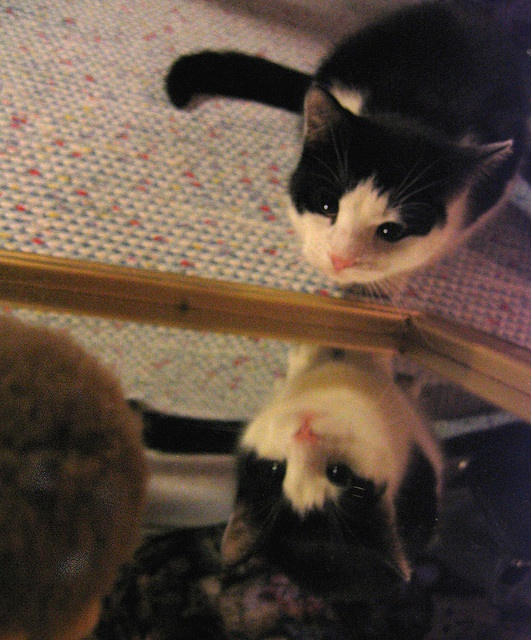Describe the objects in this image and their specific colors. I can see cat in gray, black, tan, and maroon tones, cat in gray, black, brown, and tan tones, and people in gray, black, and maroon tones in this image. 